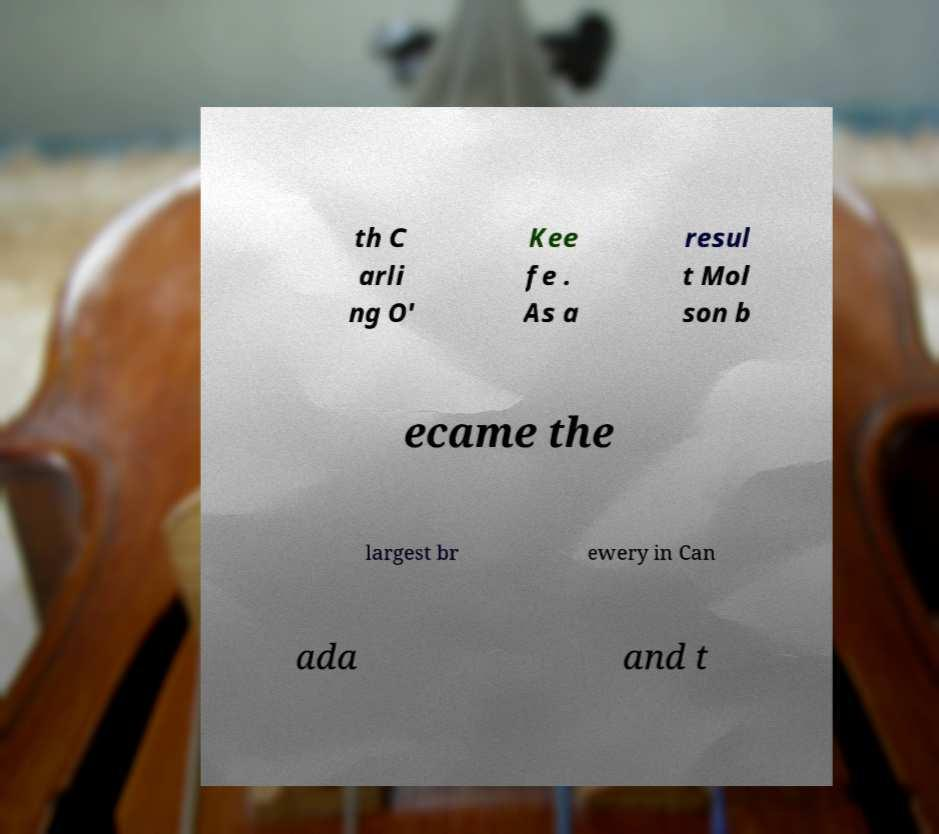Can you read and provide the text displayed in the image?This photo seems to have some interesting text. Can you extract and type it out for me? th C arli ng O' Kee fe . As a resul t Mol son b ecame the largest br ewery in Can ada and t 